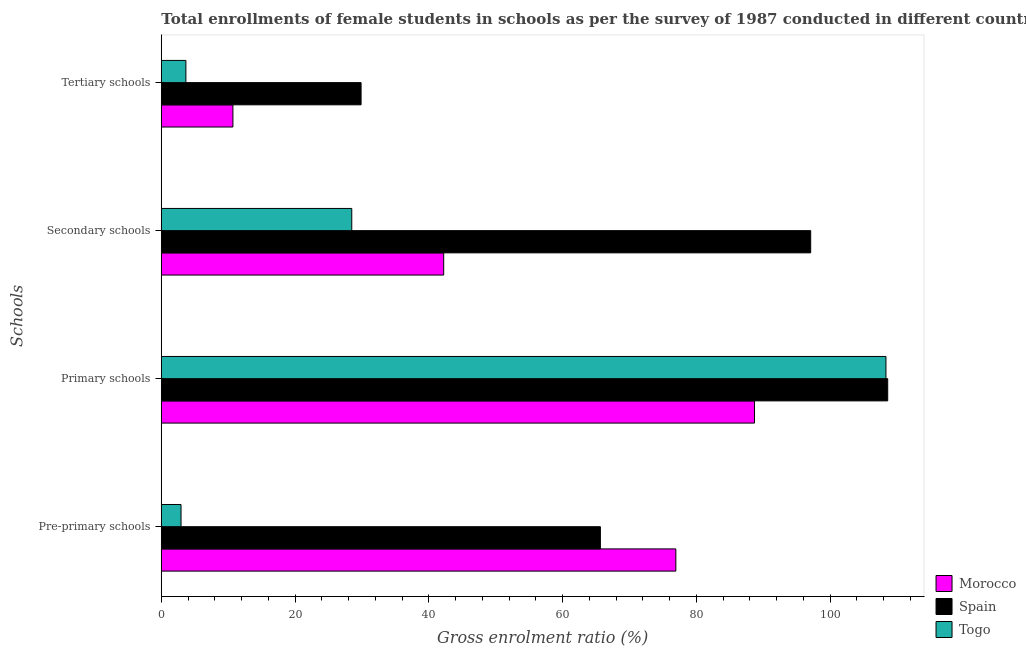Are the number of bars per tick equal to the number of legend labels?
Provide a succinct answer. Yes. Are the number of bars on each tick of the Y-axis equal?
Your answer should be very brief. Yes. How many bars are there on the 3rd tick from the bottom?
Your answer should be very brief. 3. What is the label of the 3rd group of bars from the top?
Give a very brief answer. Primary schools. What is the gross enrolment ratio(female) in pre-primary schools in Morocco?
Give a very brief answer. 76.94. Across all countries, what is the maximum gross enrolment ratio(female) in primary schools?
Your answer should be very brief. 108.62. Across all countries, what is the minimum gross enrolment ratio(female) in tertiary schools?
Make the answer very short. 3.68. In which country was the gross enrolment ratio(female) in secondary schools minimum?
Offer a terse response. Togo. What is the total gross enrolment ratio(female) in secondary schools in the graph?
Your answer should be compact. 167.8. What is the difference between the gross enrolment ratio(female) in secondary schools in Morocco and that in Togo?
Your answer should be compact. 13.75. What is the difference between the gross enrolment ratio(female) in pre-primary schools in Morocco and the gross enrolment ratio(female) in primary schools in Spain?
Your answer should be compact. -31.68. What is the average gross enrolment ratio(female) in primary schools per country?
Give a very brief answer. 101.9. What is the difference between the gross enrolment ratio(female) in pre-primary schools and gross enrolment ratio(female) in primary schools in Togo?
Your answer should be very brief. -105.41. What is the ratio of the gross enrolment ratio(female) in pre-primary schools in Spain to that in Togo?
Offer a terse response. 22.28. Is the gross enrolment ratio(female) in tertiary schools in Morocco less than that in Togo?
Your answer should be very brief. No. Is the difference between the gross enrolment ratio(female) in pre-primary schools in Spain and Morocco greater than the difference between the gross enrolment ratio(female) in secondary schools in Spain and Morocco?
Offer a terse response. No. What is the difference between the highest and the second highest gross enrolment ratio(female) in pre-primary schools?
Your answer should be very brief. 11.28. What is the difference between the highest and the lowest gross enrolment ratio(female) in pre-primary schools?
Your answer should be very brief. 73.99. In how many countries, is the gross enrolment ratio(female) in secondary schools greater than the average gross enrolment ratio(female) in secondary schools taken over all countries?
Offer a terse response. 1. Is the sum of the gross enrolment ratio(female) in secondary schools in Morocco and Spain greater than the maximum gross enrolment ratio(female) in tertiary schools across all countries?
Keep it short and to the point. Yes. What does the 1st bar from the top in Secondary schools represents?
Your answer should be compact. Togo. What does the 3rd bar from the bottom in Secondary schools represents?
Give a very brief answer. Togo. How many bars are there?
Your answer should be compact. 12. Does the graph contain grids?
Your answer should be very brief. No. How are the legend labels stacked?
Keep it short and to the point. Vertical. What is the title of the graph?
Your answer should be very brief. Total enrollments of female students in schools as per the survey of 1987 conducted in different countries. Does "Latvia" appear as one of the legend labels in the graph?
Keep it short and to the point. No. What is the label or title of the X-axis?
Give a very brief answer. Gross enrolment ratio (%). What is the label or title of the Y-axis?
Ensure brevity in your answer.  Schools. What is the Gross enrolment ratio (%) in Morocco in Pre-primary schools?
Your answer should be compact. 76.94. What is the Gross enrolment ratio (%) in Spain in Pre-primary schools?
Make the answer very short. 65.66. What is the Gross enrolment ratio (%) in Togo in Pre-primary schools?
Ensure brevity in your answer.  2.95. What is the Gross enrolment ratio (%) in Morocco in Primary schools?
Offer a terse response. 88.7. What is the Gross enrolment ratio (%) of Spain in Primary schools?
Your answer should be compact. 108.62. What is the Gross enrolment ratio (%) in Togo in Primary schools?
Keep it short and to the point. 108.36. What is the Gross enrolment ratio (%) of Morocco in Secondary schools?
Provide a succinct answer. 42.22. What is the Gross enrolment ratio (%) in Spain in Secondary schools?
Offer a very short reply. 97.1. What is the Gross enrolment ratio (%) of Togo in Secondary schools?
Your answer should be very brief. 28.48. What is the Gross enrolment ratio (%) in Morocco in Tertiary schools?
Provide a succinct answer. 10.71. What is the Gross enrolment ratio (%) in Spain in Tertiary schools?
Your response must be concise. 29.87. What is the Gross enrolment ratio (%) in Togo in Tertiary schools?
Your response must be concise. 3.68. Across all Schools, what is the maximum Gross enrolment ratio (%) in Morocco?
Your response must be concise. 88.7. Across all Schools, what is the maximum Gross enrolment ratio (%) in Spain?
Your response must be concise. 108.62. Across all Schools, what is the maximum Gross enrolment ratio (%) of Togo?
Provide a succinct answer. 108.36. Across all Schools, what is the minimum Gross enrolment ratio (%) of Morocco?
Keep it short and to the point. 10.71. Across all Schools, what is the minimum Gross enrolment ratio (%) in Spain?
Keep it short and to the point. 29.87. Across all Schools, what is the minimum Gross enrolment ratio (%) of Togo?
Offer a very short reply. 2.95. What is the total Gross enrolment ratio (%) of Morocco in the graph?
Your answer should be compact. 218.58. What is the total Gross enrolment ratio (%) of Spain in the graph?
Offer a very short reply. 301.25. What is the total Gross enrolment ratio (%) in Togo in the graph?
Provide a succinct answer. 143.46. What is the difference between the Gross enrolment ratio (%) of Morocco in Pre-primary schools and that in Primary schools?
Offer a terse response. -11.77. What is the difference between the Gross enrolment ratio (%) of Spain in Pre-primary schools and that in Primary schools?
Provide a short and direct response. -42.96. What is the difference between the Gross enrolment ratio (%) of Togo in Pre-primary schools and that in Primary schools?
Offer a very short reply. -105.41. What is the difference between the Gross enrolment ratio (%) in Morocco in Pre-primary schools and that in Secondary schools?
Your answer should be compact. 34.72. What is the difference between the Gross enrolment ratio (%) of Spain in Pre-primary schools and that in Secondary schools?
Your answer should be compact. -31.44. What is the difference between the Gross enrolment ratio (%) of Togo in Pre-primary schools and that in Secondary schools?
Keep it short and to the point. -25.53. What is the difference between the Gross enrolment ratio (%) in Morocco in Pre-primary schools and that in Tertiary schools?
Offer a very short reply. 66.23. What is the difference between the Gross enrolment ratio (%) in Spain in Pre-primary schools and that in Tertiary schools?
Make the answer very short. 35.79. What is the difference between the Gross enrolment ratio (%) of Togo in Pre-primary schools and that in Tertiary schools?
Give a very brief answer. -0.73. What is the difference between the Gross enrolment ratio (%) in Morocco in Primary schools and that in Secondary schools?
Offer a terse response. 46.48. What is the difference between the Gross enrolment ratio (%) of Spain in Primary schools and that in Secondary schools?
Give a very brief answer. 11.52. What is the difference between the Gross enrolment ratio (%) of Togo in Primary schools and that in Secondary schools?
Offer a very short reply. 79.88. What is the difference between the Gross enrolment ratio (%) of Morocco in Primary schools and that in Tertiary schools?
Your answer should be very brief. 78. What is the difference between the Gross enrolment ratio (%) in Spain in Primary schools and that in Tertiary schools?
Give a very brief answer. 78.75. What is the difference between the Gross enrolment ratio (%) in Togo in Primary schools and that in Tertiary schools?
Offer a very short reply. 104.68. What is the difference between the Gross enrolment ratio (%) in Morocco in Secondary schools and that in Tertiary schools?
Keep it short and to the point. 31.52. What is the difference between the Gross enrolment ratio (%) in Spain in Secondary schools and that in Tertiary schools?
Your answer should be compact. 67.23. What is the difference between the Gross enrolment ratio (%) in Togo in Secondary schools and that in Tertiary schools?
Keep it short and to the point. 24.8. What is the difference between the Gross enrolment ratio (%) of Morocco in Pre-primary schools and the Gross enrolment ratio (%) of Spain in Primary schools?
Offer a terse response. -31.68. What is the difference between the Gross enrolment ratio (%) in Morocco in Pre-primary schools and the Gross enrolment ratio (%) in Togo in Primary schools?
Provide a succinct answer. -31.42. What is the difference between the Gross enrolment ratio (%) in Spain in Pre-primary schools and the Gross enrolment ratio (%) in Togo in Primary schools?
Make the answer very short. -42.7. What is the difference between the Gross enrolment ratio (%) of Morocco in Pre-primary schools and the Gross enrolment ratio (%) of Spain in Secondary schools?
Provide a short and direct response. -20.16. What is the difference between the Gross enrolment ratio (%) in Morocco in Pre-primary schools and the Gross enrolment ratio (%) in Togo in Secondary schools?
Give a very brief answer. 48.46. What is the difference between the Gross enrolment ratio (%) in Spain in Pre-primary schools and the Gross enrolment ratio (%) in Togo in Secondary schools?
Offer a very short reply. 37.18. What is the difference between the Gross enrolment ratio (%) in Morocco in Pre-primary schools and the Gross enrolment ratio (%) in Spain in Tertiary schools?
Offer a terse response. 47.07. What is the difference between the Gross enrolment ratio (%) of Morocco in Pre-primary schools and the Gross enrolment ratio (%) of Togo in Tertiary schools?
Offer a terse response. 73.26. What is the difference between the Gross enrolment ratio (%) of Spain in Pre-primary schools and the Gross enrolment ratio (%) of Togo in Tertiary schools?
Provide a succinct answer. 61.98. What is the difference between the Gross enrolment ratio (%) of Morocco in Primary schools and the Gross enrolment ratio (%) of Spain in Secondary schools?
Your response must be concise. -8.4. What is the difference between the Gross enrolment ratio (%) of Morocco in Primary schools and the Gross enrolment ratio (%) of Togo in Secondary schools?
Offer a very short reply. 60.23. What is the difference between the Gross enrolment ratio (%) in Spain in Primary schools and the Gross enrolment ratio (%) in Togo in Secondary schools?
Offer a terse response. 80.14. What is the difference between the Gross enrolment ratio (%) of Morocco in Primary schools and the Gross enrolment ratio (%) of Spain in Tertiary schools?
Your answer should be compact. 58.83. What is the difference between the Gross enrolment ratio (%) in Morocco in Primary schools and the Gross enrolment ratio (%) in Togo in Tertiary schools?
Offer a terse response. 85.03. What is the difference between the Gross enrolment ratio (%) of Spain in Primary schools and the Gross enrolment ratio (%) of Togo in Tertiary schools?
Give a very brief answer. 104.95. What is the difference between the Gross enrolment ratio (%) in Morocco in Secondary schools and the Gross enrolment ratio (%) in Spain in Tertiary schools?
Your answer should be very brief. 12.35. What is the difference between the Gross enrolment ratio (%) in Morocco in Secondary schools and the Gross enrolment ratio (%) in Togo in Tertiary schools?
Provide a short and direct response. 38.55. What is the difference between the Gross enrolment ratio (%) of Spain in Secondary schools and the Gross enrolment ratio (%) of Togo in Tertiary schools?
Provide a short and direct response. 93.43. What is the average Gross enrolment ratio (%) in Morocco per Schools?
Provide a short and direct response. 54.64. What is the average Gross enrolment ratio (%) in Spain per Schools?
Offer a very short reply. 75.31. What is the average Gross enrolment ratio (%) in Togo per Schools?
Your answer should be very brief. 35.86. What is the difference between the Gross enrolment ratio (%) in Morocco and Gross enrolment ratio (%) in Spain in Pre-primary schools?
Make the answer very short. 11.28. What is the difference between the Gross enrolment ratio (%) in Morocco and Gross enrolment ratio (%) in Togo in Pre-primary schools?
Your answer should be compact. 73.99. What is the difference between the Gross enrolment ratio (%) of Spain and Gross enrolment ratio (%) of Togo in Pre-primary schools?
Offer a terse response. 62.71. What is the difference between the Gross enrolment ratio (%) of Morocco and Gross enrolment ratio (%) of Spain in Primary schools?
Your response must be concise. -19.92. What is the difference between the Gross enrolment ratio (%) of Morocco and Gross enrolment ratio (%) of Togo in Primary schools?
Make the answer very short. -19.65. What is the difference between the Gross enrolment ratio (%) in Spain and Gross enrolment ratio (%) in Togo in Primary schools?
Offer a very short reply. 0.26. What is the difference between the Gross enrolment ratio (%) in Morocco and Gross enrolment ratio (%) in Spain in Secondary schools?
Provide a succinct answer. -54.88. What is the difference between the Gross enrolment ratio (%) in Morocco and Gross enrolment ratio (%) in Togo in Secondary schools?
Your answer should be very brief. 13.75. What is the difference between the Gross enrolment ratio (%) of Spain and Gross enrolment ratio (%) of Togo in Secondary schools?
Provide a short and direct response. 68.63. What is the difference between the Gross enrolment ratio (%) of Morocco and Gross enrolment ratio (%) of Spain in Tertiary schools?
Provide a succinct answer. -19.16. What is the difference between the Gross enrolment ratio (%) in Morocco and Gross enrolment ratio (%) in Togo in Tertiary schools?
Your answer should be compact. 7.03. What is the difference between the Gross enrolment ratio (%) of Spain and Gross enrolment ratio (%) of Togo in Tertiary schools?
Ensure brevity in your answer.  26.2. What is the ratio of the Gross enrolment ratio (%) of Morocco in Pre-primary schools to that in Primary schools?
Keep it short and to the point. 0.87. What is the ratio of the Gross enrolment ratio (%) of Spain in Pre-primary schools to that in Primary schools?
Offer a very short reply. 0.6. What is the ratio of the Gross enrolment ratio (%) in Togo in Pre-primary schools to that in Primary schools?
Give a very brief answer. 0.03. What is the ratio of the Gross enrolment ratio (%) of Morocco in Pre-primary schools to that in Secondary schools?
Offer a terse response. 1.82. What is the ratio of the Gross enrolment ratio (%) of Spain in Pre-primary schools to that in Secondary schools?
Provide a short and direct response. 0.68. What is the ratio of the Gross enrolment ratio (%) in Togo in Pre-primary schools to that in Secondary schools?
Make the answer very short. 0.1. What is the ratio of the Gross enrolment ratio (%) of Morocco in Pre-primary schools to that in Tertiary schools?
Provide a short and direct response. 7.19. What is the ratio of the Gross enrolment ratio (%) in Spain in Pre-primary schools to that in Tertiary schools?
Provide a short and direct response. 2.2. What is the ratio of the Gross enrolment ratio (%) in Togo in Pre-primary schools to that in Tertiary schools?
Your answer should be very brief. 0.8. What is the ratio of the Gross enrolment ratio (%) of Morocco in Primary schools to that in Secondary schools?
Give a very brief answer. 2.1. What is the ratio of the Gross enrolment ratio (%) of Spain in Primary schools to that in Secondary schools?
Keep it short and to the point. 1.12. What is the ratio of the Gross enrolment ratio (%) in Togo in Primary schools to that in Secondary schools?
Provide a succinct answer. 3.81. What is the ratio of the Gross enrolment ratio (%) of Morocco in Primary schools to that in Tertiary schools?
Your response must be concise. 8.28. What is the ratio of the Gross enrolment ratio (%) of Spain in Primary schools to that in Tertiary schools?
Keep it short and to the point. 3.64. What is the ratio of the Gross enrolment ratio (%) in Togo in Primary schools to that in Tertiary schools?
Give a very brief answer. 29.48. What is the ratio of the Gross enrolment ratio (%) in Morocco in Secondary schools to that in Tertiary schools?
Ensure brevity in your answer.  3.94. What is the ratio of the Gross enrolment ratio (%) in Spain in Secondary schools to that in Tertiary schools?
Offer a very short reply. 3.25. What is the ratio of the Gross enrolment ratio (%) in Togo in Secondary schools to that in Tertiary schools?
Your answer should be compact. 7.75. What is the difference between the highest and the second highest Gross enrolment ratio (%) in Morocco?
Make the answer very short. 11.77. What is the difference between the highest and the second highest Gross enrolment ratio (%) in Spain?
Provide a short and direct response. 11.52. What is the difference between the highest and the second highest Gross enrolment ratio (%) of Togo?
Your answer should be compact. 79.88. What is the difference between the highest and the lowest Gross enrolment ratio (%) in Morocco?
Provide a short and direct response. 78. What is the difference between the highest and the lowest Gross enrolment ratio (%) of Spain?
Your answer should be compact. 78.75. What is the difference between the highest and the lowest Gross enrolment ratio (%) in Togo?
Keep it short and to the point. 105.41. 